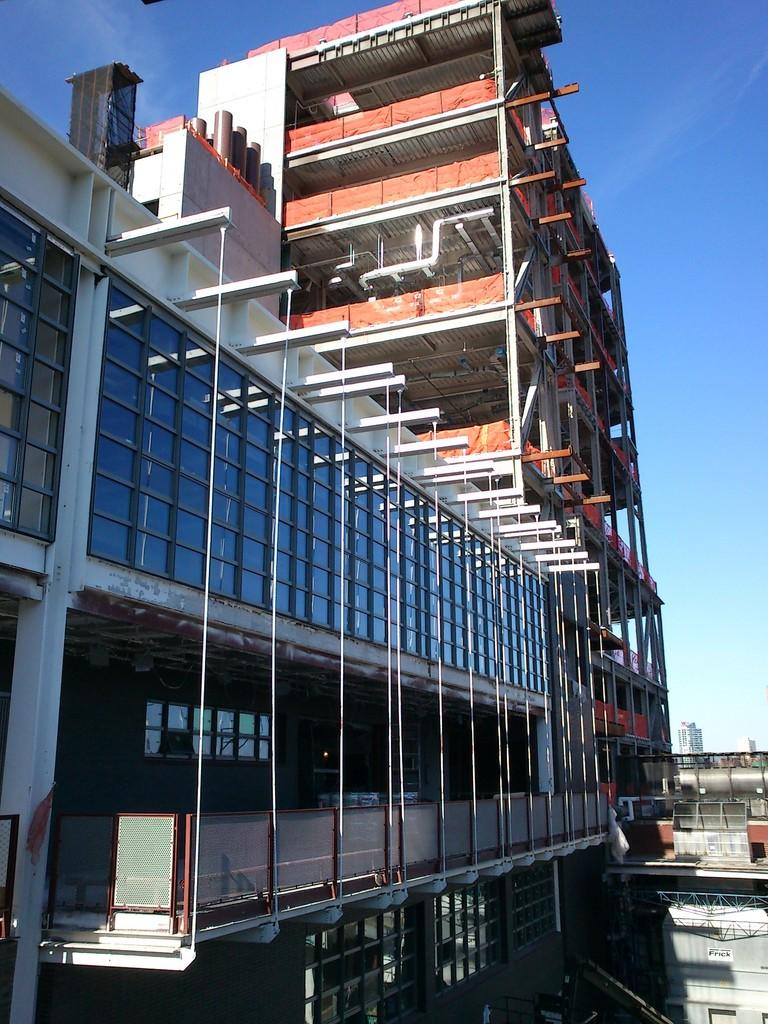What type of structures can be seen in the image? There are buildings in the image. What else can be seen in the image besides the buildings? There are pipelines in the image. What part of the natural environment is visible in the image? The sky is visible in the image. What type of plate is being used to hold the pipelines in the image? There is no plate present in the image; the pipelines are not being held by a plate. 